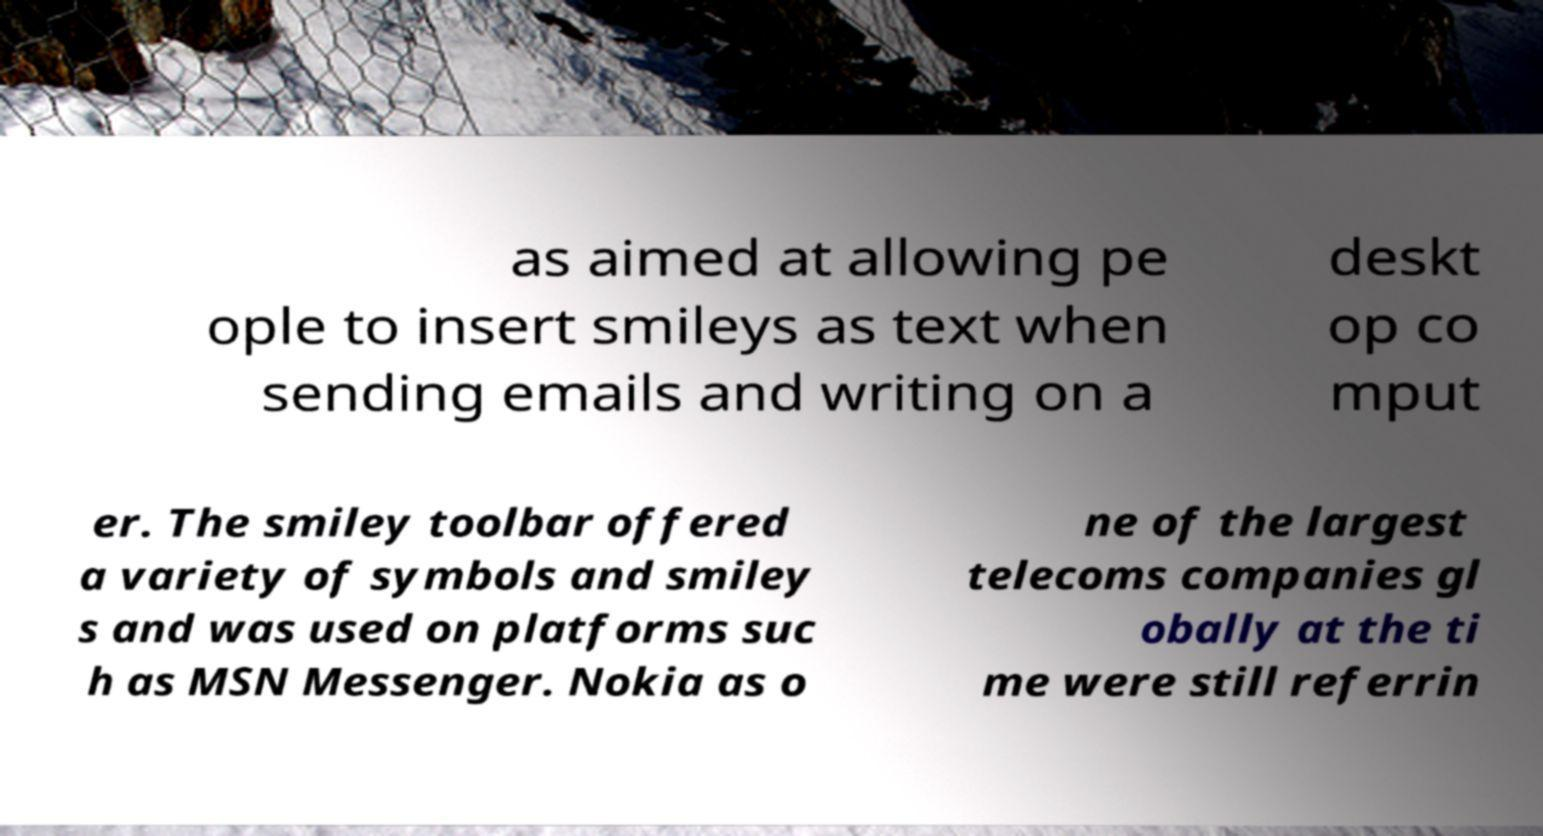Please identify and transcribe the text found in this image. as aimed at allowing pe ople to insert smileys as text when sending emails and writing on a deskt op co mput er. The smiley toolbar offered a variety of symbols and smiley s and was used on platforms suc h as MSN Messenger. Nokia as o ne of the largest telecoms companies gl obally at the ti me were still referrin 